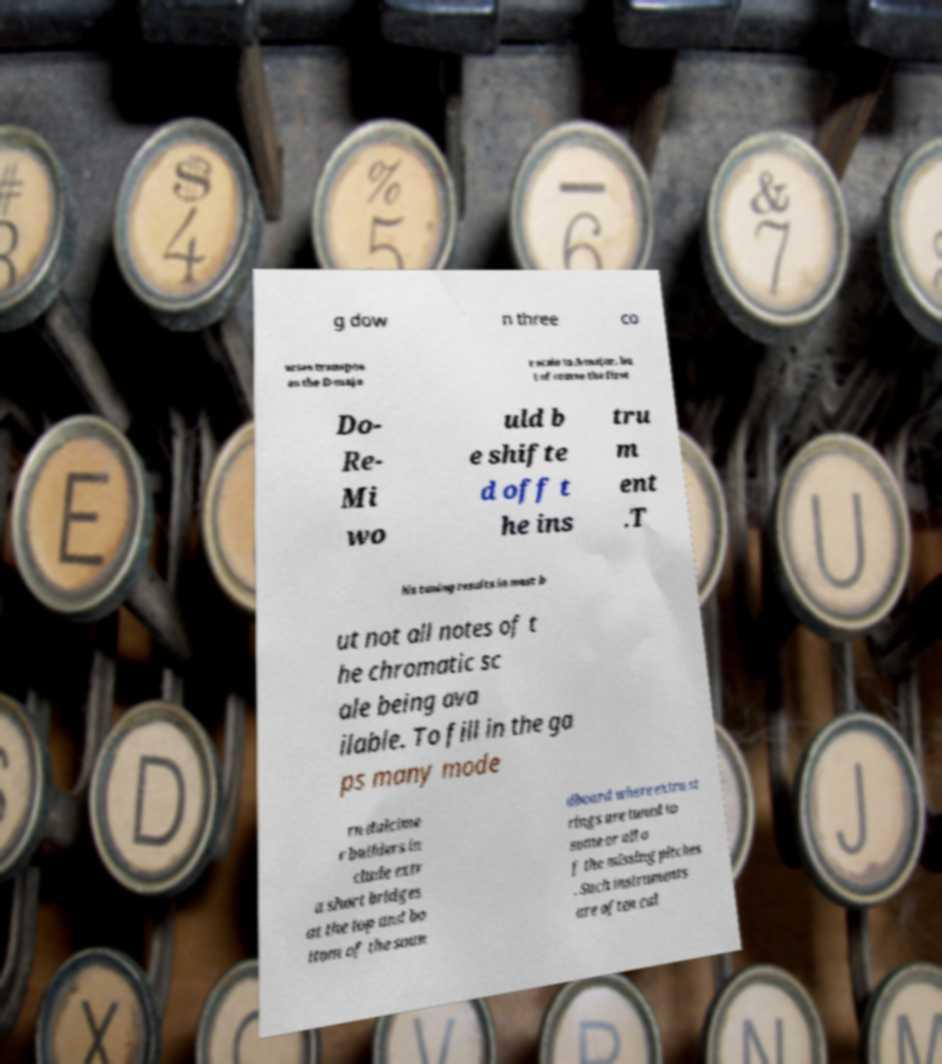Can you accurately transcribe the text from the provided image for me? g dow n three co urses transpos es the D-majo r scale to A-major, bu t of course the first Do- Re- Mi wo uld b e shifte d off t he ins tru m ent .T his tuning results in most b ut not all notes of t he chromatic sc ale being ava ilable. To fill in the ga ps many mode rn dulcime r builders in clude extr a short bridges at the top and bo ttom of the soun dboard where extra st rings are tuned to some or all o f the missing pitches . Such instruments are often cal 